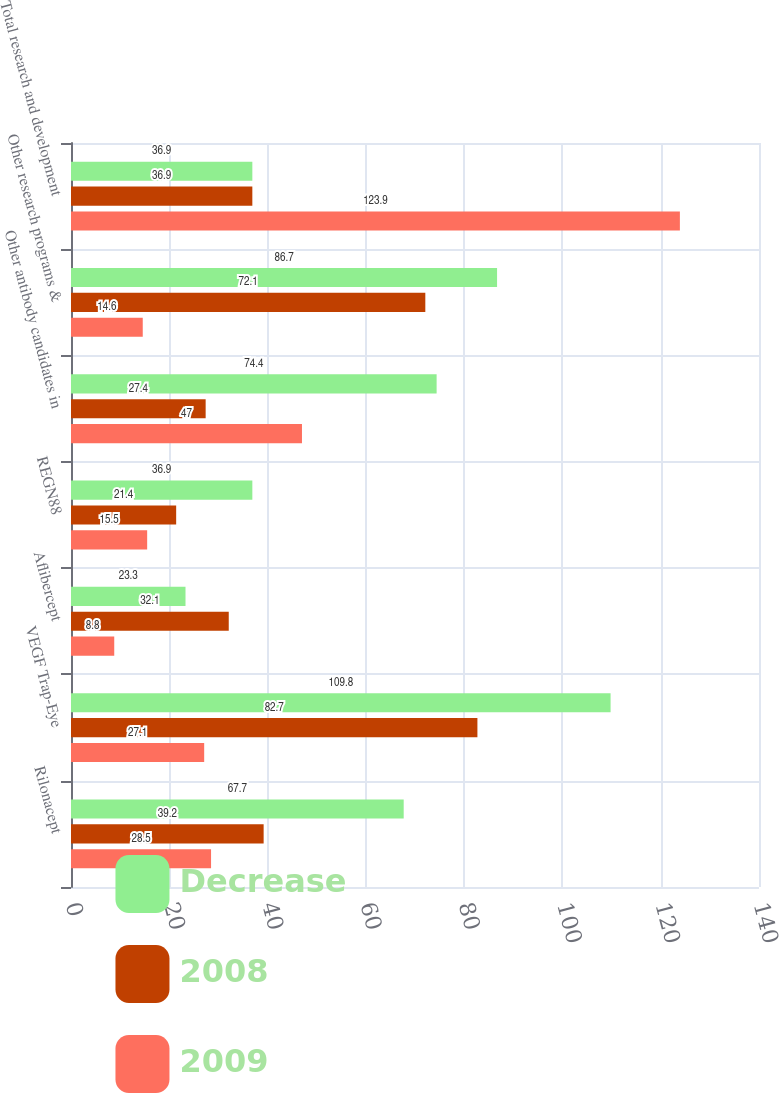Convert chart. <chart><loc_0><loc_0><loc_500><loc_500><stacked_bar_chart><ecel><fcel>Rilonacept<fcel>VEGF Trap-Eye<fcel>Aflibercept<fcel>REGN88<fcel>Other antibody candidates in<fcel>Other research programs &<fcel>Total research and development<nl><fcel>Decrease<fcel>67.7<fcel>109.8<fcel>23.3<fcel>36.9<fcel>74.4<fcel>86.7<fcel>36.9<nl><fcel>2008<fcel>39.2<fcel>82.7<fcel>32.1<fcel>21.4<fcel>27.4<fcel>72.1<fcel>36.9<nl><fcel>2009<fcel>28.5<fcel>27.1<fcel>8.8<fcel>15.5<fcel>47<fcel>14.6<fcel>123.9<nl></chart> 